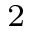Convert formula to latex. <formula><loc_0><loc_0><loc_500><loc_500>_ { 2 }</formula> 